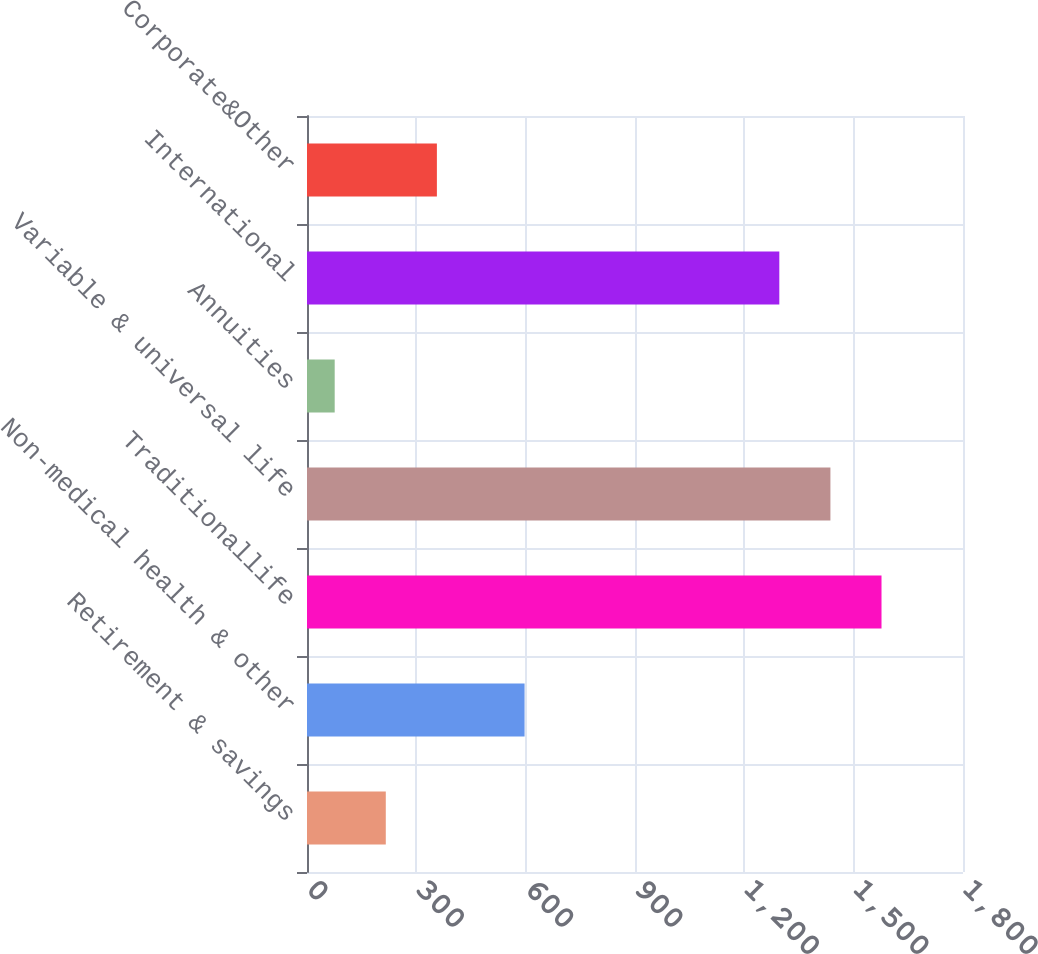<chart> <loc_0><loc_0><loc_500><loc_500><bar_chart><fcel>Retirement & savings<fcel>Non-medical health & other<fcel>Traditionallife<fcel>Variable & universal life<fcel>Annuities<fcel>International<fcel>Corporate&Other<nl><fcel>216.2<fcel>597<fcel>1576.4<fcel>1436.2<fcel>76<fcel>1296<fcel>356.4<nl></chart> 